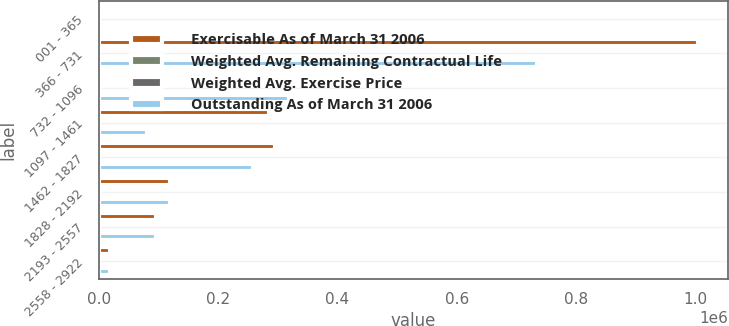Convert chart. <chart><loc_0><loc_0><loc_500><loc_500><stacked_bar_chart><ecel><fcel>001 - 365<fcel>366 - 731<fcel>732 - 1096<fcel>1097 - 1461<fcel>1462 - 1827<fcel>1828 - 2192<fcel>2193 - 2557<fcel>2558 - 2922<nl><fcel>Exercisable As of March 31 2006<fcel>6848<fcel>1.00382e+06<fcel>27.17<fcel>285500<fcel>295600<fcel>119400<fcel>95000<fcel>19000<nl><fcel>Weighted Avg. Remaining Contractual Life<fcel>7.8<fcel>4.7<fcel>8.8<fcel>8<fcel>5<fcel>4.6<fcel>5.2<fcel>3.9<nl><fcel>Weighted Avg. Exercise Price<fcel>0.01<fcel>6.31<fcel>9.55<fcel>12.18<fcel>15.56<fcel>18.77<fcel>24.12<fcel>27.17<nl><fcel>Outstanding As of March 31 2006<fcel>5069<fcel>734105<fcel>318028<fcel>81250<fcel>258100<fcel>119400<fcel>95000<fcel>19000<nl></chart> 